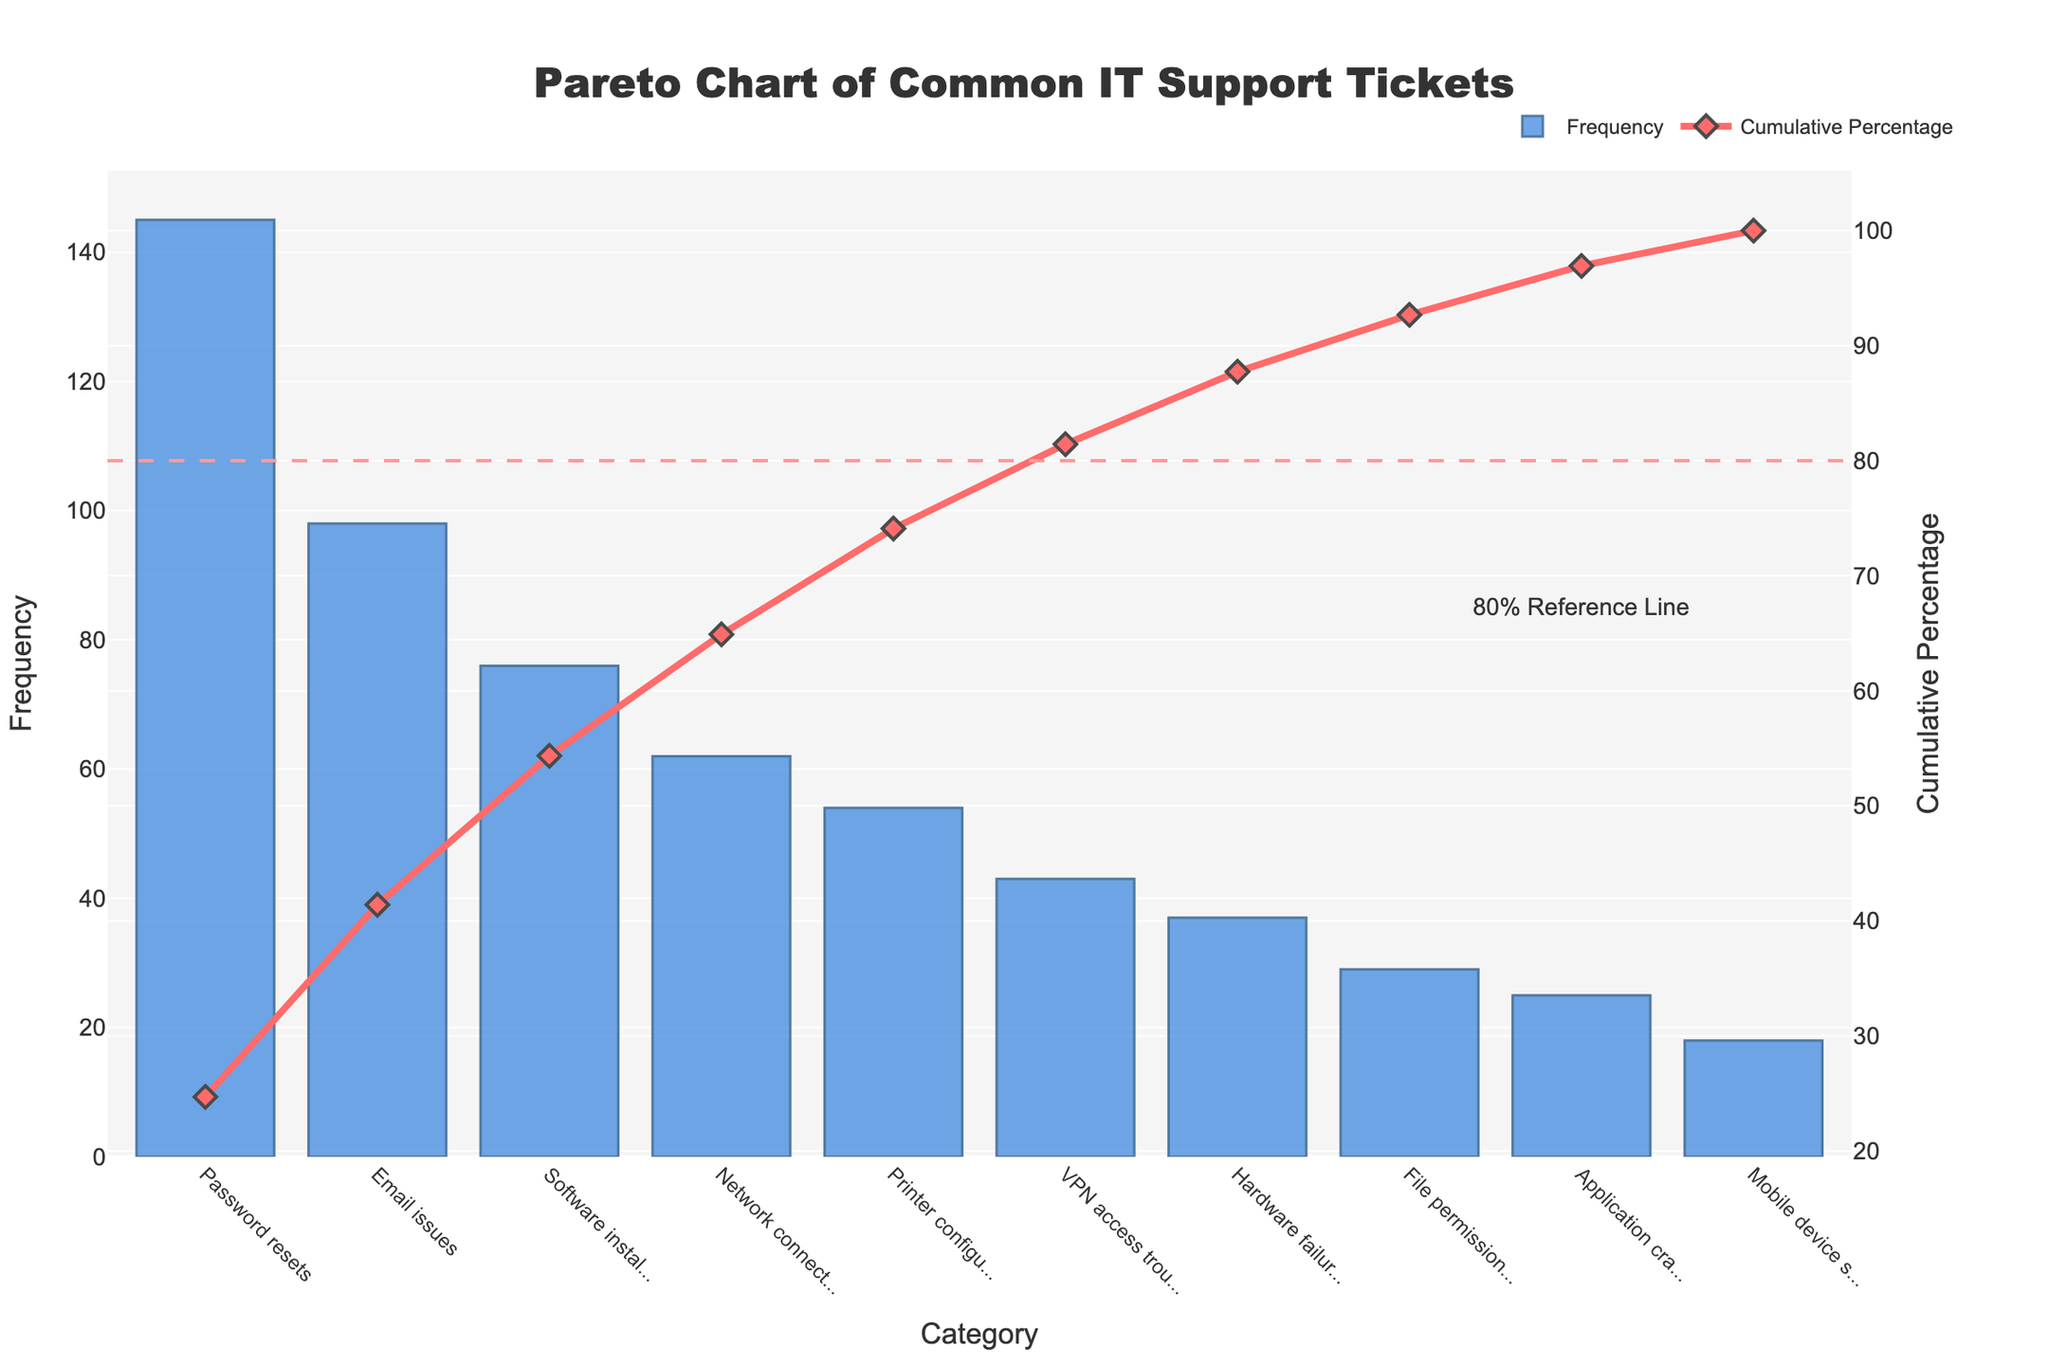What's the title of the Pareto chart? The title is displayed at the top of the chart. It reads: "Pareto Chart of Common IT Support Tickets".
Answer: Pareto Chart of Common IT Support Tickets How many categories are represented in the chart? Count the number of unique categories listed along the x-axis. There are 10 categories.
Answer: 10 What is the color of the bars showing frequency? The bars have shades of blue. The primary color appears bluish, with a slightly darker hue for the outlines.
Answer: Blue Which IT support category has the highest frequency of tickets? The tallest bar represents the category with the highest frequency. This bar corresponds to "Password resets".
Answer: Password resets What percentage of the total tickets does the "Email issues" category represent? Find "Email issues" on the x-axis, then check its cumulative percentage on the secondary y-axis (right side). The percentage is shown through the line graph.
Answer: Approximately 26% By looking at the chart, which two categories, when combined, make up approximately 50% of the total tickets? Identify the categories with the highest frequencies. Combine their cumulative percentages. "Password resets" (~30%) and "Email issues" (~26%) together make up nearly 56%.
Answer: Password resets and Email issues How many total tickets are represented in this chart? Sum all the frequencies listed. 145 + 98 + 76 + 62 + 54 + 43 + 37 + 29 + 25 + 18 = 587 tickets.
Answer: 587 Which category is placed just before the 80% reference line on the cumulative percentage graph? Look at the cumulative percentage line and find the category just before it reaches the dashed 80% reference line. The preceding category is "Hardware failures".
Answer: Hardware failures Which category represents the lowest frequency of tickets? The category with the shortest bar indicates the lowest frequency. This category is "Mobile device synchronization".
Answer: Mobile device synchronization What is the cumulative percentage of tickets by the fourth category listed? The fourth category's cumulative percentage, based on the order of the x-axis, is "Network connectivity problems". This category reaches around 68% on the secondary y-axis.
Answer: Around 68% 